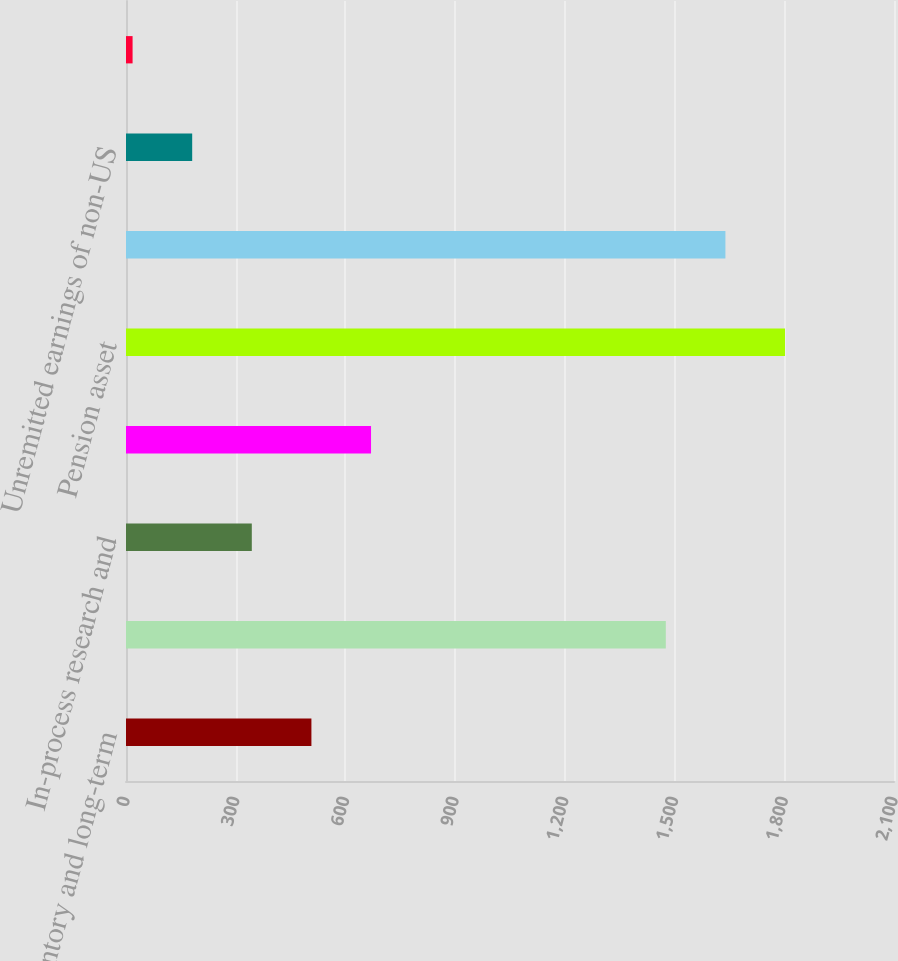<chart> <loc_0><loc_0><loc_500><loc_500><bar_chart><fcel>Inventory and long-term<fcel>Other employee benefits<fcel>In-process research and<fcel>Net operating loss credit and<fcel>Pension asset<fcel>Customer and commercial<fcel>Unremitted earnings of non-US<fcel>Other net unrealized losses<nl><fcel>507<fcel>1476<fcel>344<fcel>670<fcel>1802<fcel>1639<fcel>181<fcel>18<nl></chart> 